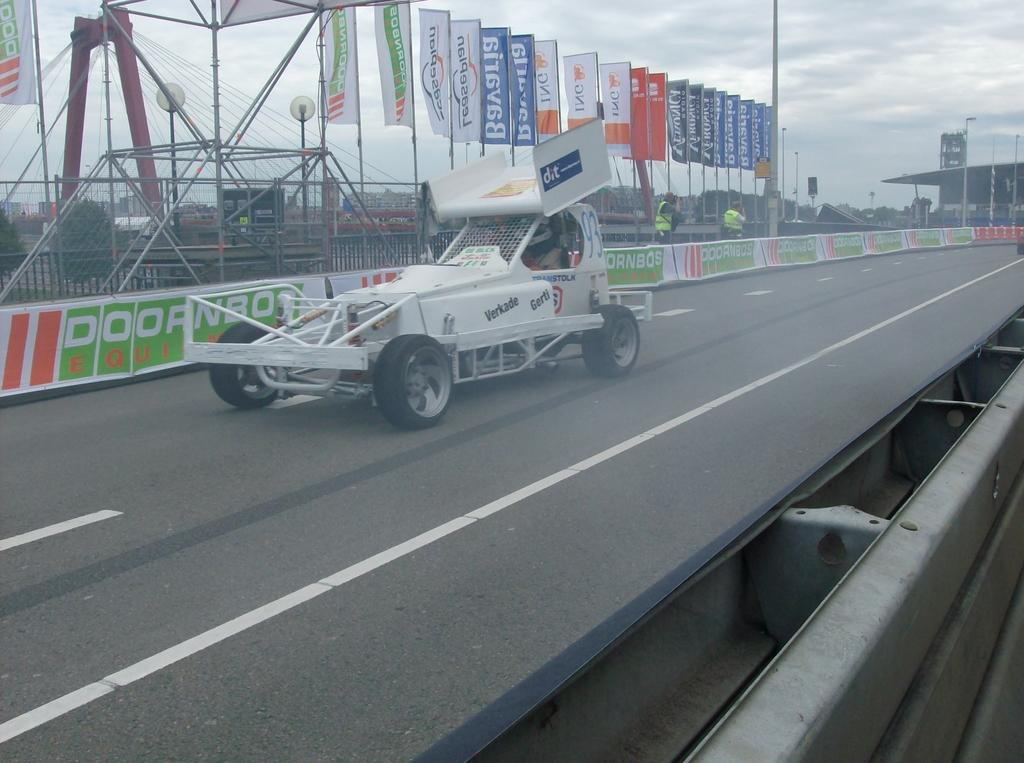What is the color of the vehicle on the road? The vehicle on the road is white. What can be seen in the background of the image? There are flags in the background. What is written on the flags? The flags have something written on them. Can you see a ghost driving the white vehicle in the image? No, there is no ghost present in the image. 